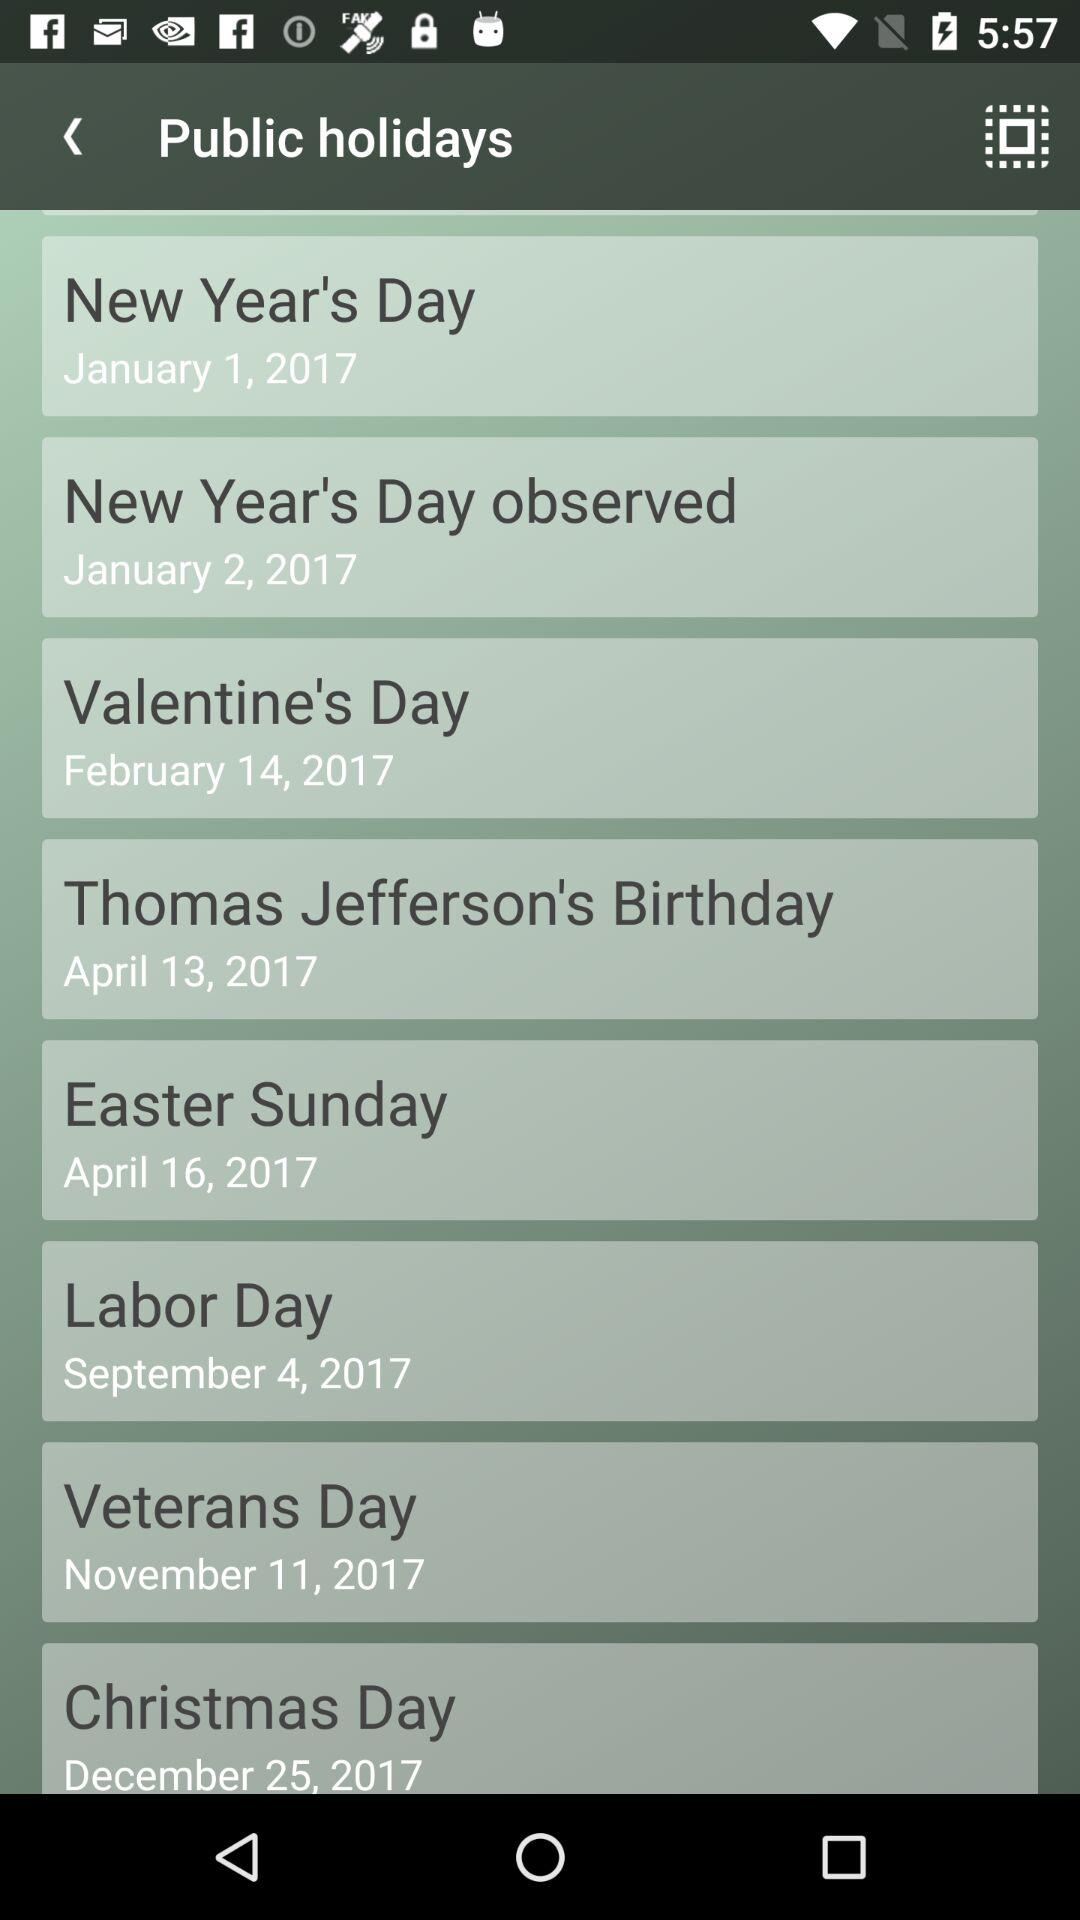What date is Veterans Day? Veterans Day is on November 11, 2017. 